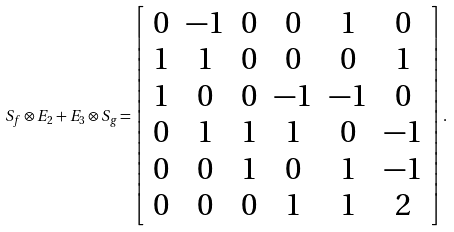<formula> <loc_0><loc_0><loc_500><loc_500>S _ { f } \otimes E _ { 2 } + E _ { 3 } \otimes S _ { g } = \left [ \begin{array} { c c c c c c } 0 & - 1 & 0 & 0 & 1 & 0 \\ 1 & 1 & 0 & 0 & 0 & 1 \\ 1 & 0 & 0 & - 1 & - 1 & 0 \\ 0 & 1 & 1 & 1 & 0 & - 1 \\ 0 & 0 & 1 & 0 & 1 & - 1 \\ 0 & 0 & 0 & 1 & 1 & 2 \end{array} \right ] .</formula> 